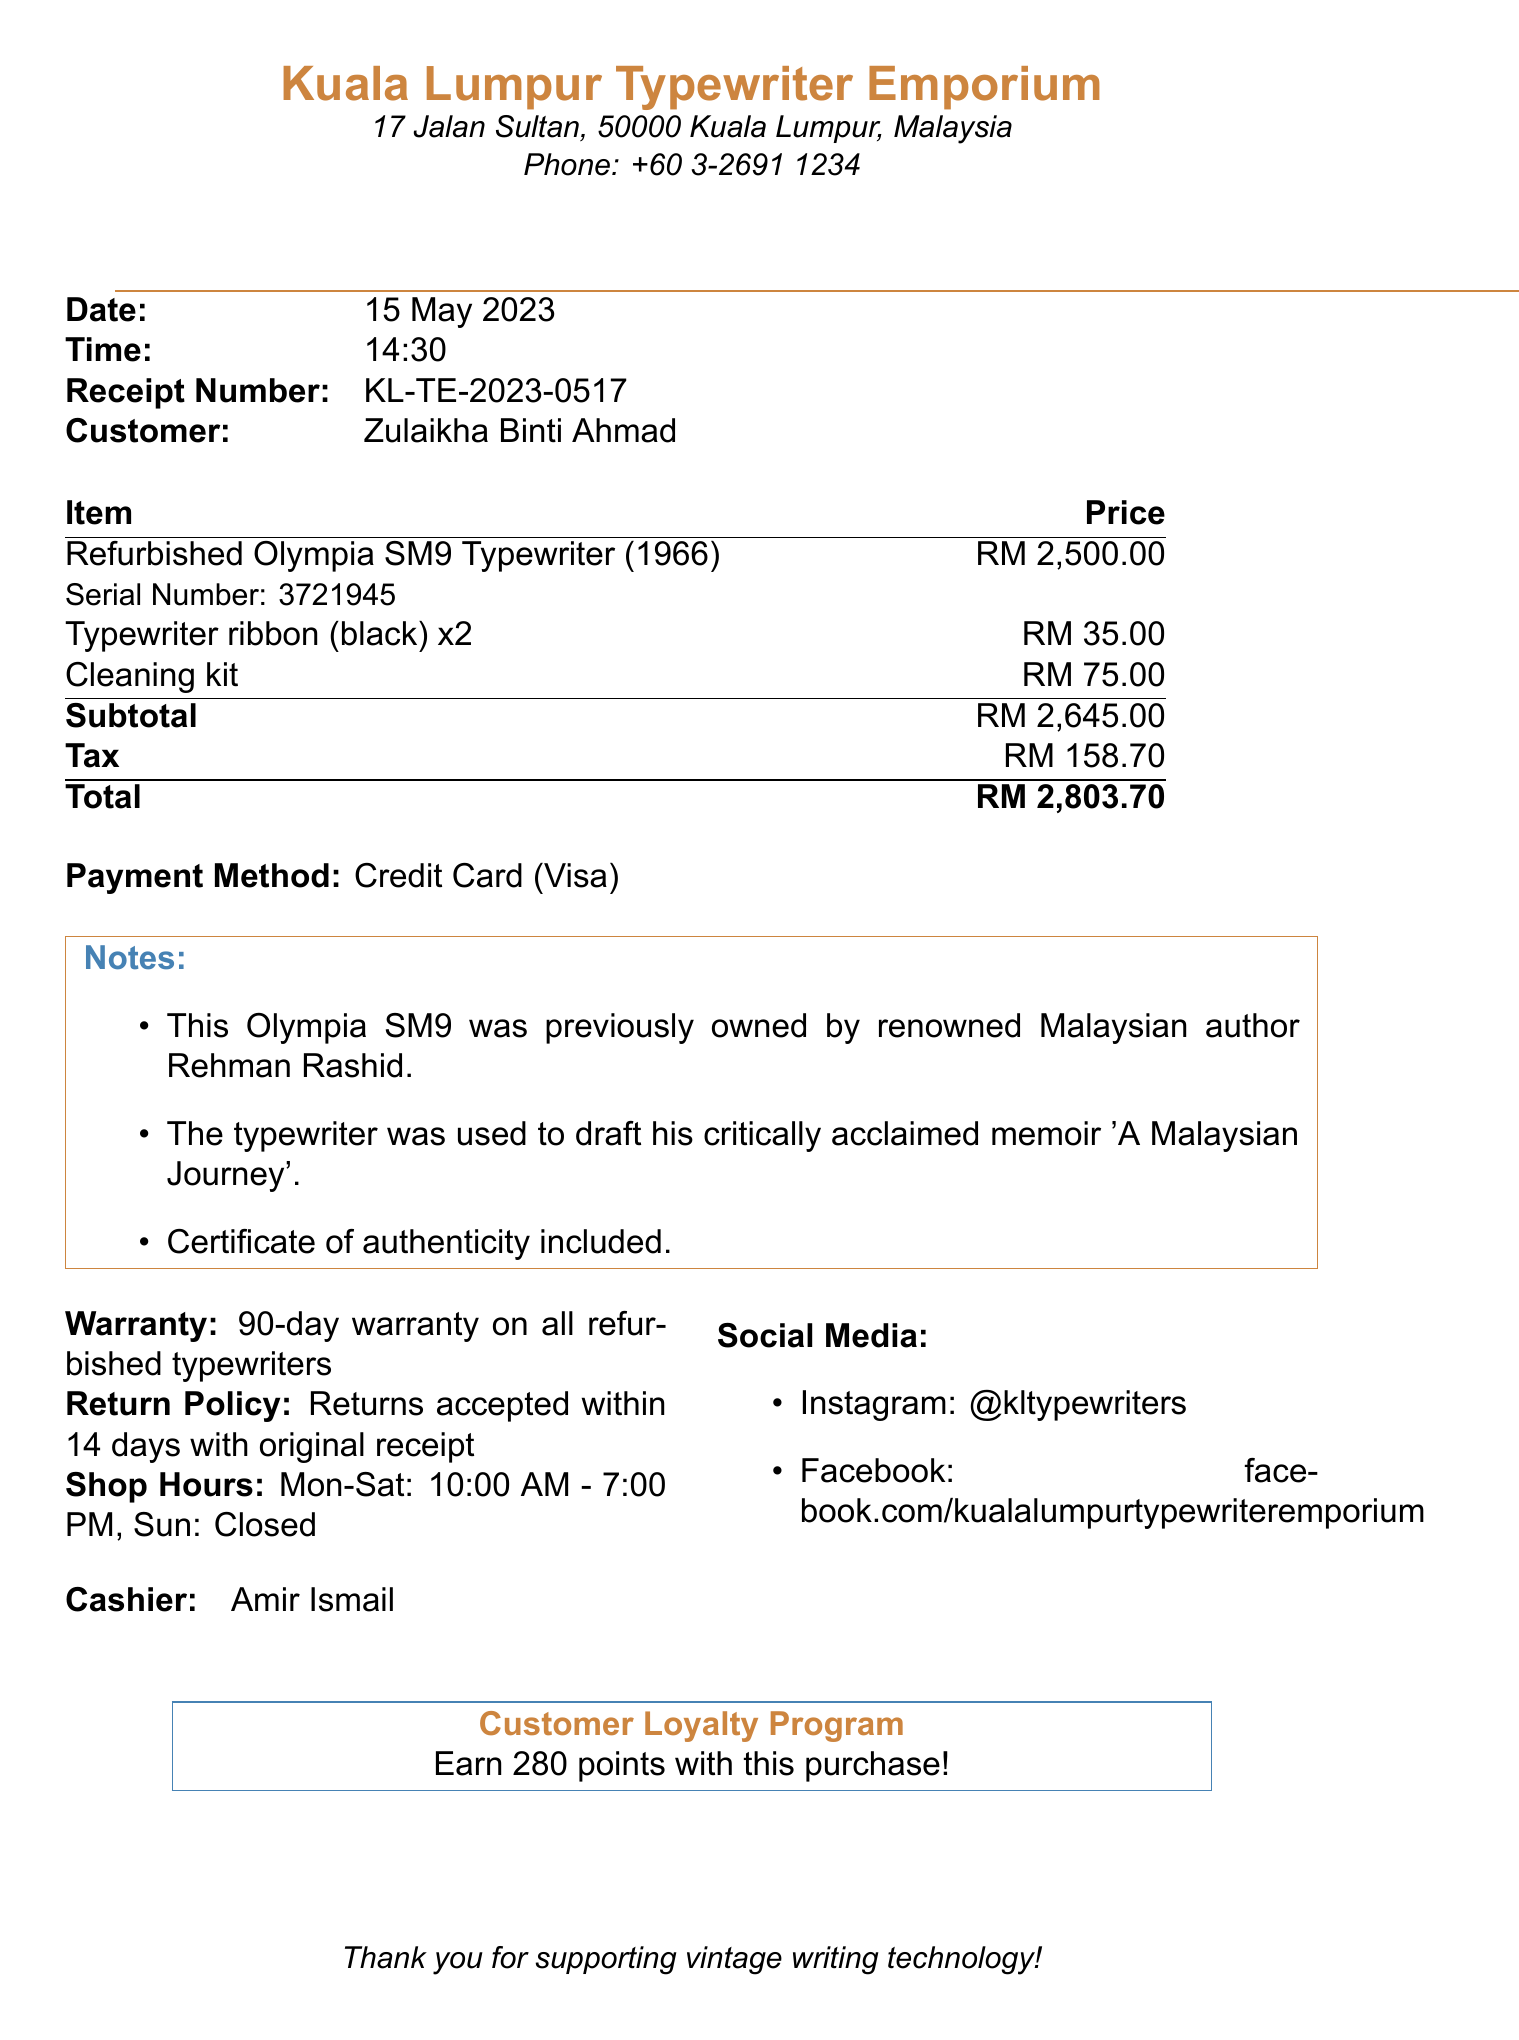what is the name of the shop? The shop name is stated at the top of the receipt.
Answer: Kuala Lumpur Typewriter Emporium who was the previous owner of the typewriter? The receipt includes a note detailing the previous owner of the typewriter.
Answer: Rehman Rashid what is the total amount paid? The total amount is calculated as the sum of the subtotal and tax on the receipt.
Answer: RM 2,803.70 how much is the warranty period? The warranty period is specifically mentioned in the document.
Answer: 90-day warranty what item was purchased for RM 2,500.00? The description of the item with that price is noted in the itemized list.
Answer: Refurbished Olympia SM9 Typewriter (1966) how many typewriter ribbons were purchased? The receipt lists the quantity of the typewriter ribbons in the itemized details.
Answer: 2 when is the return policy valid until? The return policy is specified in the receipt, outlining the conditions for returns.
Answer: 14 days what payment method was used? The payment method is clearly indicated in the payment section of the receipt.
Answer: Credit Card (Visa) what is the subtotal before tax? The subtotal amount is provided in the itemized list of charges.
Answer: RM 2,645.00 